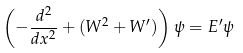<formula> <loc_0><loc_0><loc_500><loc_500>\left ( - \frac { d ^ { 2 } } { d x ^ { 2 } } + ( W ^ { 2 } + W ^ { \prime } ) \right ) \psi = E ^ { \prime } \psi</formula> 